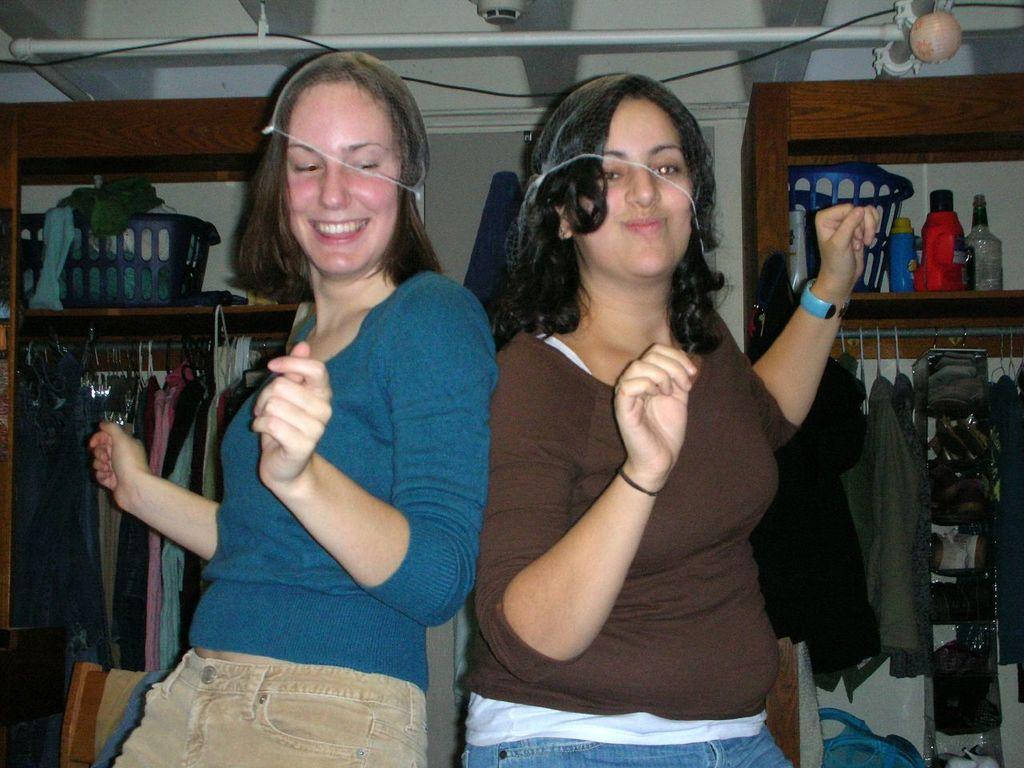Please provide a concise description of this image. Here we can see two women are dancing and both are smiling. In the background we can see clothes hanging to a pole,basket and other objects on the racks. At the top there is a pole,cable and wall. 